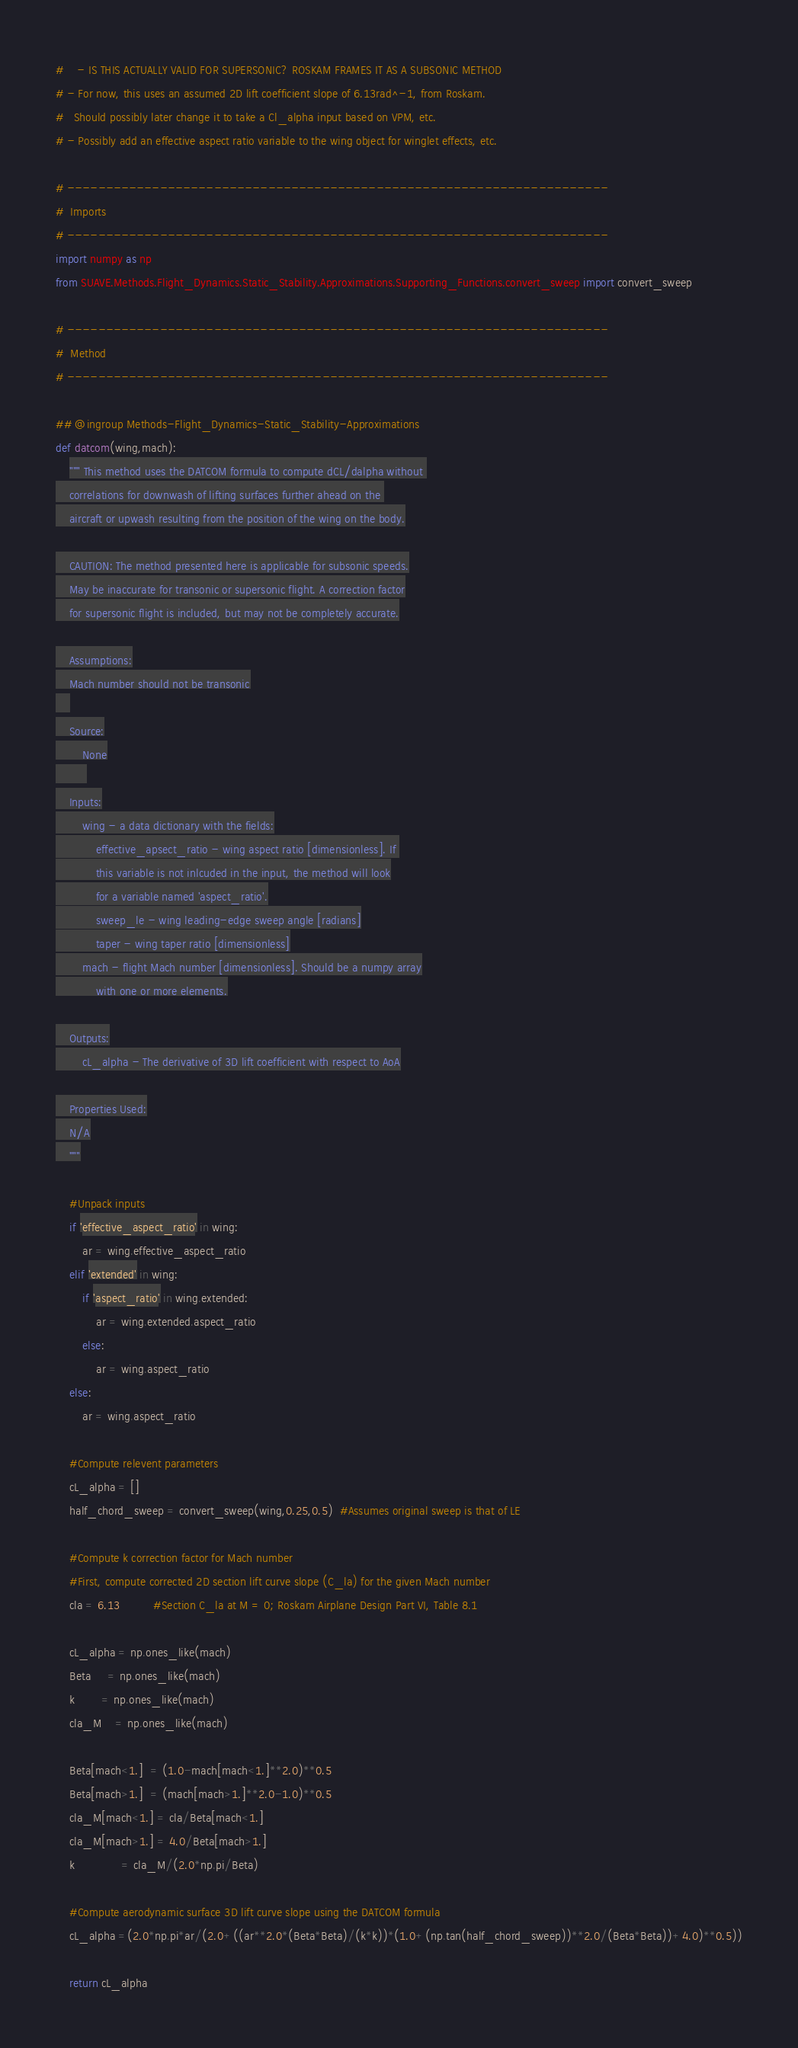<code> <loc_0><loc_0><loc_500><loc_500><_Python_>#    - IS THIS ACTUALLY VALID FOR SUPERSONIC? ROSKAM FRAMES IT AS A SUBSONIC METHOD
# - For now, this uses an assumed 2D lift coefficient slope of 6.13rad^-1, from Roskam.
#   Should possibly later change it to take a Cl_alpha input based on VPM, etc.
# - Possibly add an effective aspect ratio variable to the wing object for winglet effects, etc.

# ----------------------------------------------------------------------
#  Imports
# ----------------------------------------------------------------------
import numpy as np
from SUAVE.Methods.Flight_Dynamics.Static_Stability.Approximations.Supporting_Functions.convert_sweep import convert_sweep

# ----------------------------------------------------------------------
#  Method
# ----------------------------------------------------------------------

## @ingroup Methods-Flight_Dynamics-Static_Stability-Approximations
def datcom(wing,mach):
    """ This method uses the DATCOM formula to compute dCL/dalpha without 
    correlations for downwash of lifting surfaces further ahead on the 
    aircraft or upwash resulting from the position of the wing on the body.

    CAUTION: The method presented here is applicable for subsonic speeds.
    May be inaccurate for transonic or supersonic flight. A correction factor
    for supersonic flight is included, but may not be completely accurate.

    Assumptions:
    Mach number should not be transonic
    
    Source:
        None
         
    Inputs:
        wing - a data dictionary with the fields:
            effective_apsect_ratio - wing aspect ratio [dimensionless]. If 
            this variable is not inlcuded in the input, the method will look
            for a variable named 'aspect_ratio'.
            sweep_le - wing leading-edge sweep angle [radians]
            taper - wing taper ratio [dimensionless]
        mach - flight Mach number [dimensionless]. Should be a numpy array
            with one or more elements.

    Outputs:
        cL_alpha - The derivative of 3D lift coefficient with respect to AoA

    Properties Used:
    N/A
    """         
    
    #Unpack inputs
    if 'effective_aspect_ratio' in wing:
        ar = wing.effective_aspect_ratio
    elif 'extended' in wing:
        if 'aspect_ratio' in wing.extended:
            ar = wing.extended.aspect_ratio
        else:
            ar = wing.aspect_ratio
    else:
        ar = wing.aspect_ratio    
        
    #Compute relevent parameters
    cL_alpha = []
    half_chord_sweep = convert_sweep(wing,0.25,0.5)  #Assumes original sweep is that of LE
    
    #Compute k correction factor for Mach number    
    #First, compute corrected 2D section lift curve slope (C_la) for the given Mach number
    cla = 6.13          #Section C_la at M = 0; Roskam Airplane Design Part VI, Table 8.1  
    
    cL_alpha = np.ones_like(mach)
    Beta     = np.ones_like(mach)
    k        = np.ones_like(mach)
    cla_M    = np.ones_like(mach)
    
    Beta[mach<1.]  = (1.0-mach[mach<1.]**2.0)**0.5
    Beta[mach>1.]  = (mach[mach>1.]**2.0-1.0)**0.5
    cla_M[mach<1.] = cla/Beta[mach<1.]
    cla_M[mach>1.] = 4.0/Beta[mach>1.]
    k              = cla_M/(2.0*np.pi/Beta)
    
    #Compute aerodynamic surface 3D lift curve slope using the DATCOM formula
    cL_alpha =(2.0*np.pi*ar/(2.0+((ar**2.0*(Beta*Beta)/(k*k))*(1.0+(np.tan(half_chord_sweep))**2.0/(Beta*Beta))+4.0)**0.5))
    
    return cL_alpha
</code> 